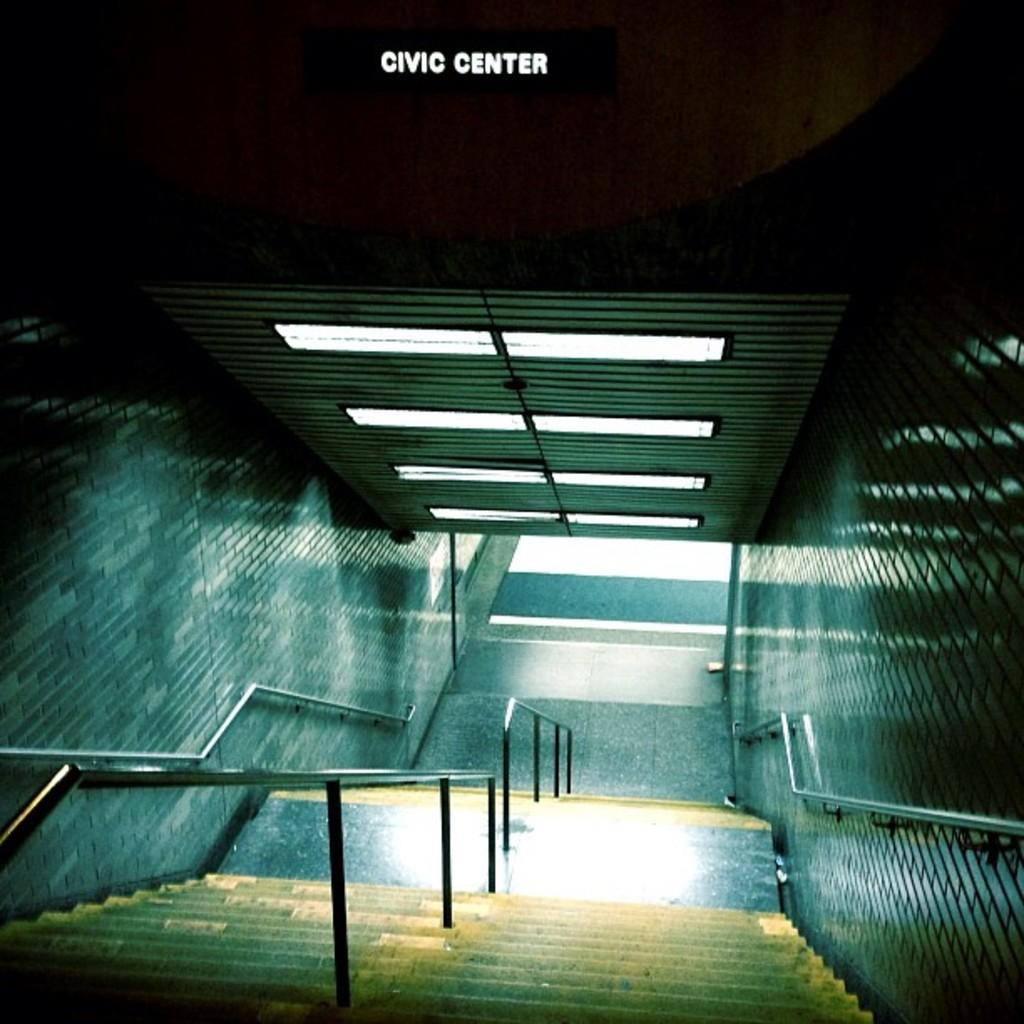What type of architectural feature is present in the image? There is a staircase with a railing in the image. What else can be seen in the image besides the staircase? There is some text visible in the image, as well as walls, a roof, and ceiling lights. What type of peace can be observed in the image? There is no reference to peace in the image, as it primarily features a staircase and other architectural elements. 